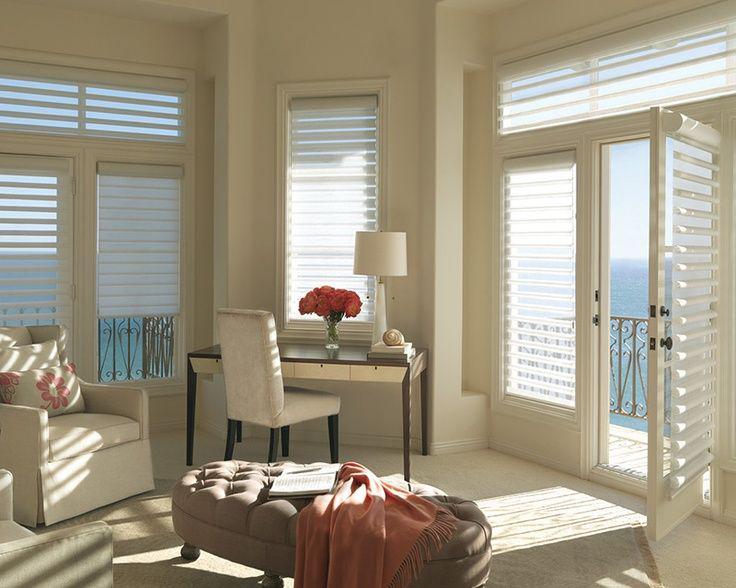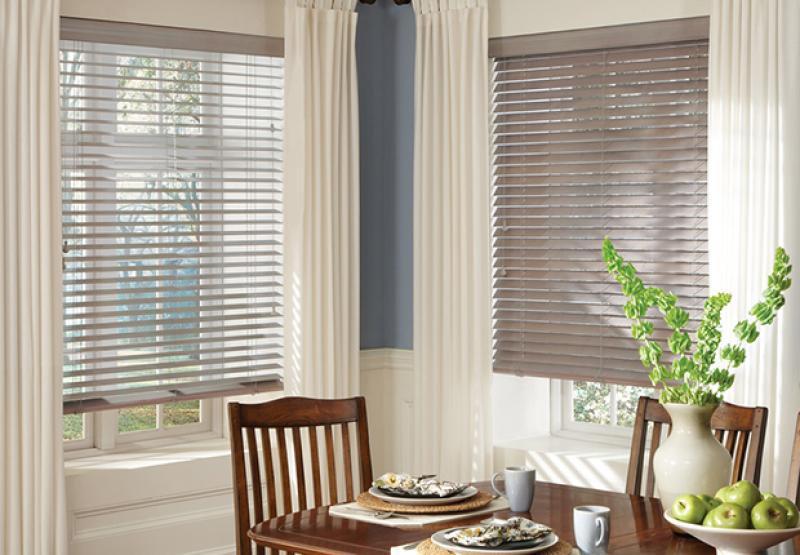The first image is the image on the left, the second image is the image on the right. Examine the images to the left and right. Is the description "A window shade is partially pulled up in the right image." accurate? Answer yes or no. Yes. The first image is the image on the left, the second image is the image on the right. Analyze the images presented: Is the assertion "There are five blinds." valid? Answer yes or no. No. 